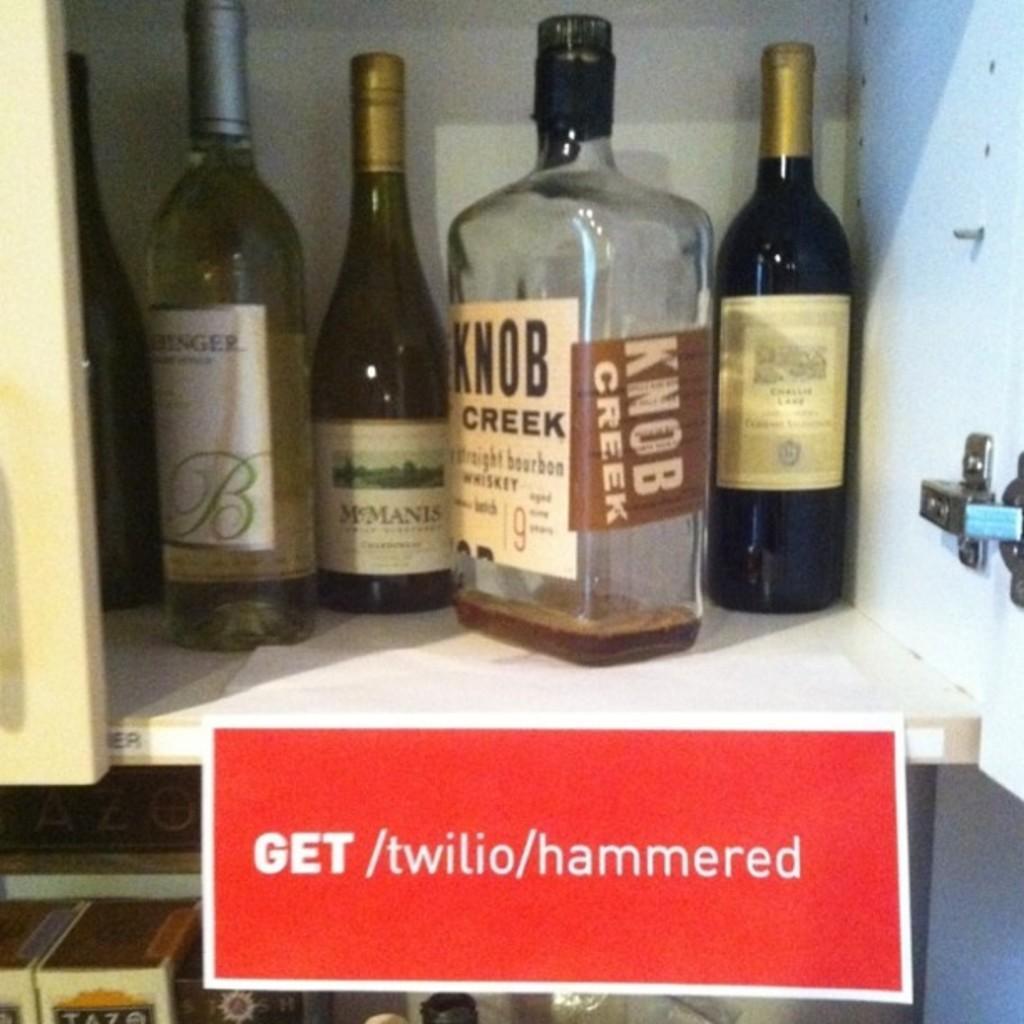Please provide a concise description of this image. In this image there are five bottles placed in cupboard. Under which a name plate is pasted. 